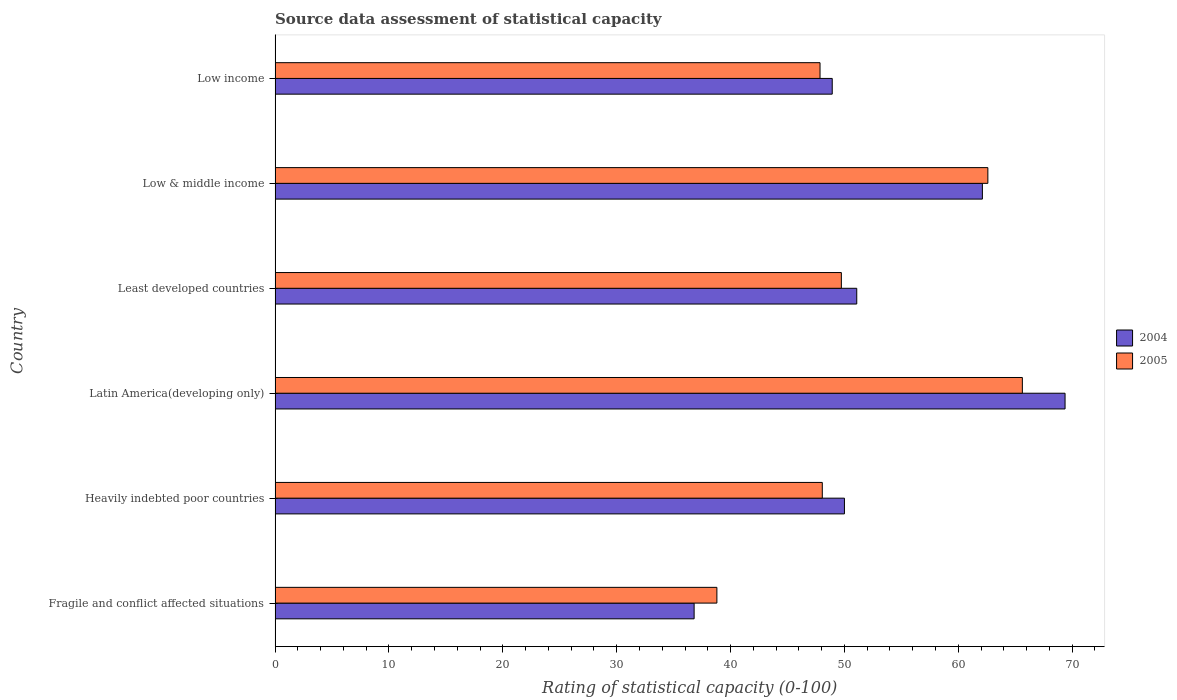How many different coloured bars are there?
Provide a short and direct response. 2. Are the number of bars per tick equal to the number of legend labels?
Give a very brief answer. Yes. Are the number of bars on each tick of the Y-axis equal?
Give a very brief answer. Yes. How many bars are there on the 3rd tick from the top?
Provide a short and direct response. 2. What is the label of the 6th group of bars from the top?
Make the answer very short. Fragile and conflict affected situations. In how many cases, is the number of bars for a given country not equal to the number of legend labels?
Provide a succinct answer. 0. What is the rating of statistical capacity in 2005 in Fragile and conflict affected situations?
Give a very brief answer. 38.8. Across all countries, what is the maximum rating of statistical capacity in 2005?
Ensure brevity in your answer.  65.62. Across all countries, what is the minimum rating of statistical capacity in 2004?
Keep it short and to the point. 36.8. In which country was the rating of statistical capacity in 2005 maximum?
Provide a succinct answer. Latin America(developing only). In which country was the rating of statistical capacity in 2004 minimum?
Offer a terse response. Fragile and conflict affected situations. What is the total rating of statistical capacity in 2005 in the graph?
Your response must be concise. 312.66. What is the difference between the rating of statistical capacity in 2005 in Least developed countries and that in Low income?
Offer a terse response. 1.87. What is the difference between the rating of statistical capacity in 2005 in Least developed countries and the rating of statistical capacity in 2004 in Low & middle income?
Give a very brief answer. -12.39. What is the average rating of statistical capacity in 2004 per country?
Offer a very short reply. 53.05. What is the difference between the rating of statistical capacity in 2004 and rating of statistical capacity in 2005 in Low income?
Make the answer very short. 1.07. In how many countries, is the rating of statistical capacity in 2005 greater than 14 ?
Provide a succinct answer. 6. What is the ratio of the rating of statistical capacity in 2005 in Fragile and conflict affected situations to that in Least developed countries?
Your response must be concise. 0.78. Is the rating of statistical capacity in 2004 in Heavily indebted poor countries less than that in Low & middle income?
Provide a short and direct response. Yes. Is the difference between the rating of statistical capacity in 2004 in Heavily indebted poor countries and Low & middle income greater than the difference between the rating of statistical capacity in 2005 in Heavily indebted poor countries and Low & middle income?
Ensure brevity in your answer.  Yes. What is the difference between the highest and the second highest rating of statistical capacity in 2004?
Your answer should be very brief. 7.26. What is the difference between the highest and the lowest rating of statistical capacity in 2004?
Make the answer very short. 32.58. What does the 2nd bar from the bottom in Least developed countries represents?
Provide a succinct answer. 2005. How many bars are there?
Your response must be concise. 12. Are the values on the major ticks of X-axis written in scientific E-notation?
Make the answer very short. No. Does the graph contain any zero values?
Provide a succinct answer. No. Does the graph contain grids?
Provide a succinct answer. No. Where does the legend appear in the graph?
Make the answer very short. Center right. How many legend labels are there?
Your answer should be compact. 2. What is the title of the graph?
Keep it short and to the point. Source data assessment of statistical capacity. Does "1968" appear as one of the legend labels in the graph?
Provide a succinct answer. No. What is the label or title of the X-axis?
Offer a very short reply. Rating of statistical capacity (0-100). What is the label or title of the Y-axis?
Provide a succinct answer. Country. What is the Rating of statistical capacity (0-100) in 2004 in Fragile and conflict affected situations?
Your answer should be compact. 36.8. What is the Rating of statistical capacity (0-100) of 2005 in Fragile and conflict affected situations?
Your answer should be compact. 38.8. What is the Rating of statistical capacity (0-100) of 2005 in Heavily indebted poor countries?
Provide a short and direct response. 48.06. What is the Rating of statistical capacity (0-100) in 2004 in Latin America(developing only)?
Ensure brevity in your answer.  69.38. What is the Rating of statistical capacity (0-100) in 2005 in Latin America(developing only)?
Your response must be concise. 65.62. What is the Rating of statistical capacity (0-100) of 2004 in Least developed countries?
Provide a short and direct response. 51.08. What is the Rating of statistical capacity (0-100) in 2005 in Least developed countries?
Offer a terse response. 49.73. What is the Rating of statistical capacity (0-100) in 2004 in Low & middle income?
Offer a terse response. 62.12. What is the Rating of statistical capacity (0-100) in 2005 in Low & middle income?
Offer a very short reply. 62.6. What is the Rating of statistical capacity (0-100) of 2004 in Low income?
Give a very brief answer. 48.93. What is the Rating of statistical capacity (0-100) of 2005 in Low income?
Ensure brevity in your answer.  47.86. Across all countries, what is the maximum Rating of statistical capacity (0-100) in 2004?
Ensure brevity in your answer.  69.38. Across all countries, what is the maximum Rating of statistical capacity (0-100) in 2005?
Ensure brevity in your answer.  65.62. Across all countries, what is the minimum Rating of statistical capacity (0-100) of 2004?
Offer a terse response. 36.8. Across all countries, what is the minimum Rating of statistical capacity (0-100) of 2005?
Offer a very short reply. 38.8. What is the total Rating of statistical capacity (0-100) of 2004 in the graph?
Keep it short and to the point. 318.3. What is the total Rating of statistical capacity (0-100) of 2005 in the graph?
Your answer should be very brief. 312.66. What is the difference between the Rating of statistical capacity (0-100) in 2005 in Fragile and conflict affected situations and that in Heavily indebted poor countries?
Offer a very short reply. -9.26. What is the difference between the Rating of statistical capacity (0-100) in 2004 in Fragile and conflict affected situations and that in Latin America(developing only)?
Provide a succinct answer. -32.58. What is the difference between the Rating of statistical capacity (0-100) in 2005 in Fragile and conflict affected situations and that in Latin America(developing only)?
Offer a terse response. -26.82. What is the difference between the Rating of statistical capacity (0-100) in 2004 in Fragile and conflict affected situations and that in Least developed countries?
Provide a short and direct response. -14.28. What is the difference between the Rating of statistical capacity (0-100) in 2005 in Fragile and conflict affected situations and that in Least developed countries?
Provide a succinct answer. -10.93. What is the difference between the Rating of statistical capacity (0-100) of 2004 in Fragile and conflict affected situations and that in Low & middle income?
Offer a terse response. -25.32. What is the difference between the Rating of statistical capacity (0-100) of 2005 in Fragile and conflict affected situations and that in Low & middle income?
Provide a short and direct response. -23.8. What is the difference between the Rating of statistical capacity (0-100) of 2004 in Fragile and conflict affected situations and that in Low income?
Offer a terse response. -12.13. What is the difference between the Rating of statistical capacity (0-100) of 2005 in Fragile and conflict affected situations and that in Low income?
Your response must be concise. -9.06. What is the difference between the Rating of statistical capacity (0-100) of 2004 in Heavily indebted poor countries and that in Latin America(developing only)?
Give a very brief answer. -19.38. What is the difference between the Rating of statistical capacity (0-100) in 2005 in Heavily indebted poor countries and that in Latin America(developing only)?
Ensure brevity in your answer.  -17.57. What is the difference between the Rating of statistical capacity (0-100) of 2004 in Heavily indebted poor countries and that in Least developed countries?
Provide a short and direct response. -1.08. What is the difference between the Rating of statistical capacity (0-100) of 2005 in Heavily indebted poor countries and that in Least developed countries?
Your answer should be very brief. -1.67. What is the difference between the Rating of statistical capacity (0-100) in 2004 in Heavily indebted poor countries and that in Low & middle income?
Give a very brief answer. -12.12. What is the difference between the Rating of statistical capacity (0-100) of 2005 in Heavily indebted poor countries and that in Low & middle income?
Ensure brevity in your answer.  -14.54. What is the difference between the Rating of statistical capacity (0-100) of 2004 in Heavily indebted poor countries and that in Low income?
Provide a succinct answer. 1.07. What is the difference between the Rating of statistical capacity (0-100) in 2005 in Heavily indebted poor countries and that in Low income?
Provide a succinct answer. 0.2. What is the difference between the Rating of statistical capacity (0-100) of 2004 in Latin America(developing only) and that in Least developed countries?
Offer a terse response. 18.29. What is the difference between the Rating of statistical capacity (0-100) in 2005 in Latin America(developing only) and that in Least developed countries?
Keep it short and to the point. 15.9. What is the difference between the Rating of statistical capacity (0-100) in 2004 in Latin America(developing only) and that in Low & middle income?
Ensure brevity in your answer.  7.26. What is the difference between the Rating of statistical capacity (0-100) in 2005 in Latin America(developing only) and that in Low & middle income?
Provide a succinct answer. 3.03. What is the difference between the Rating of statistical capacity (0-100) of 2004 in Latin America(developing only) and that in Low income?
Keep it short and to the point. 20.45. What is the difference between the Rating of statistical capacity (0-100) of 2005 in Latin America(developing only) and that in Low income?
Provide a short and direct response. 17.77. What is the difference between the Rating of statistical capacity (0-100) of 2004 in Least developed countries and that in Low & middle income?
Your answer should be compact. -11.03. What is the difference between the Rating of statistical capacity (0-100) of 2005 in Least developed countries and that in Low & middle income?
Offer a terse response. -12.87. What is the difference between the Rating of statistical capacity (0-100) in 2004 in Least developed countries and that in Low income?
Offer a very short reply. 2.15. What is the difference between the Rating of statistical capacity (0-100) of 2005 in Least developed countries and that in Low income?
Your response must be concise. 1.87. What is the difference between the Rating of statistical capacity (0-100) of 2004 in Low & middle income and that in Low income?
Provide a short and direct response. 13.19. What is the difference between the Rating of statistical capacity (0-100) of 2005 in Low & middle income and that in Low income?
Provide a succinct answer. 14.74. What is the difference between the Rating of statistical capacity (0-100) of 2004 in Fragile and conflict affected situations and the Rating of statistical capacity (0-100) of 2005 in Heavily indebted poor countries?
Your response must be concise. -11.26. What is the difference between the Rating of statistical capacity (0-100) in 2004 in Fragile and conflict affected situations and the Rating of statistical capacity (0-100) in 2005 in Latin America(developing only)?
Offer a very short reply. -28.82. What is the difference between the Rating of statistical capacity (0-100) of 2004 in Fragile and conflict affected situations and the Rating of statistical capacity (0-100) of 2005 in Least developed countries?
Offer a very short reply. -12.93. What is the difference between the Rating of statistical capacity (0-100) of 2004 in Fragile and conflict affected situations and the Rating of statistical capacity (0-100) of 2005 in Low & middle income?
Give a very brief answer. -25.8. What is the difference between the Rating of statistical capacity (0-100) of 2004 in Fragile and conflict affected situations and the Rating of statistical capacity (0-100) of 2005 in Low income?
Give a very brief answer. -11.06. What is the difference between the Rating of statistical capacity (0-100) of 2004 in Heavily indebted poor countries and the Rating of statistical capacity (0-100) of 2005 in Latin America(developing only)?
Your response must be concise. -15.62. What is the difference between the Rating of statistical capacity (0-100) of 2004 in Heavily indebted poor countries and the Rating of statistical capacity (0-100) of 2005 in Least developed countries?
Keep it short and to the point. 0.27. What is the difference between the Rating of statistical capacity (0-100) in 2004 in Heavily indebted poor countries and the Rating of statistical capacity (0-100) in 2005 in Low & middle income?
Provide a succinct answer. -12.6. What is the difference between the Rating of statistical capacity (0-100) in 2004 in Heavily indebted poor countries and the Rating of statistical capacity (0-100) in 2005 in Low income?
Your response must be concise. 2.14. What is the difference between the Rating of statistical capacity (0-100) in 2004 in Latin America(developing only) and the Rating of statistical capacity (0-100) in 2005 in Least developed countries?
Your response must be concise. 19.65. What is the difference between the Rating of statistical capacity (0-100) in 2004 in Latin America(developing only) and the Rating of statistical capacity (0-100) in 2005 in Low & middle income?
Keep it short and to the point. 6.78. What is the difference between the Rating of statistical capacity (0-100) in 2004 in Latin America(developing only) and the Rating of statistical capacity (0-100) in 2005 in Low income?
Your answer should be compact. 21.52. What is the difference between the Rating of statistical capacity (0-100) of 2004 in Least developed countries and the Rating of statistical capacity (0-100) of 2005 in Low & middle income?
Ensure brevity in your answer.  -11.52. What is the difference between the Rating of statistical capacity (0-100) of 2004 in Least developed countries and the Rating of statistical capacity (0-100) of 2005 in Low income?
Provide a succinct answer. 3.22. What is the difference between the Rating of statistical capacity (0-100) of 2004 in Low & middle income and the Rating of statistical capacity (0-100) of 2005 in Low income?
Your answer should be very brief. 14.26. What is the average Rating of statistical capacity (0-100) in 2004 per country?
Keep it short and to the point. 53.05. What is the average Rating of statistical capacity (0-100) in 2005 per country?
Your response must be concise. 52.11. What is the difference between the Rating of statistical capacity (0-100) in 2004 and Rating of statistical capacity (0-100) in 2005 in Heavily indebted poor countries?
Your response must be concise. 1.94. What is the difference between the Rating of statistical capacity (0-100) of 2004 and Rating of statistical capacity (0-100) of 2005 in Latin America(developing only)?
Your answer should be compact. 3.75. What is the difference between the Rating of statistical capacity (0-100) in 2004 and Rating of statistical capacity (0-100) in 2005 in Least developed countries?
Your answer should be compact. 1.35. What is the difference between the Rating of statistical capacity (0-100) of 2004 and Rating of statistical capacity (0-100) of 2005 in Low & middle income?
Your answer should be compact. -0.48. What is the difference between the Rating of statistical capacity (0-100) of 2004 and Rating of statistical capacity (0-100) of 2005 in Low income?
Keep it short and to the point. 1.07. What is the ratio of the Rating of statistical capacity (0-100) in 2004 in Fragile and conflict affected situations to that in Heavily indebted poor countries?
Offer a terse response. 0.74. What is the ratio of the Rating of statistical capacity (0-100) of 2005 in Fragile and conflict affected situations to that in Heavily indebted poor countries?
Ensure brevity in your answer.  0.81. What is the ratio of the Rating of statistical capacity (0-100) of 2004 in Fragile and conflict affected situations to that in Latin America(developing only)?
Ensure brevity in your answer.  0.53. What is the ratio of the Rating of statistical capacity (0-100) of 2005 in Fragile and conflict affected situations to that in Latin America(developing only)?
Offer a terse response. 0.59. What is the ratio of the Rating of statistical capacity (0-100) in 2004 in Fragile and conflict affected situations to that in Least developed countries?
Your answer should be very brief. 0.72. What is the ratio of the Rating of statistical capacity (0-100) in 2005 in Fragile and conflict affected situations to that in Least developed countries?
Your answer should be very brief. 0.78. What is the ratio of the Rating of statistical capacity (0-100) of 2004 in Fragile and conflict affected situations to that in Low & middle income?
Your answer should be very brief. 0.59. What is the ratio of the Rating of statistical capacity (0-100) in 2005 in Fragile and conflict affected situations to that in Low & middle income?
Provide a short and direct response. 0.62. What is the ratio of the Rating of statistical capacity (0-100) in 2004 in Fragile and conflict affected situations to that in Low income?
Offer a terse response. 0.75. What is the ratio of the Rating of statistical capacity (0-100) in 2005 in Fragile and conflict affected situations to that in Low income?
Provide a succinct answer. 0.81. What is the ratio of the Rating of statistical capacity (0-100) of 2004 in Heavily indebted poor countries to that in Latin America(developing only)?
Offer a terse response. 0.72. What is the ratio of the Rating of statistical capacity (0-100) of 2005 in Heavily indebted poor countries to that in Latin America(developing only)?
Keep it short and to the point. 0.73. What is the ratio of the Rating of statistical capacity (0-100) of 2004 in Heavily indebted poor countries to that in Least developed countries?
Your response must be concise. 0.98. What is the ratio of the Rating of statistical capacity (0-100) of 2005 in Heavily indebted poor countries to that in Least developed countries?
Offer a terse response. 0.97. What is the ratio of the Rating of statistical capacity (0-100) in 2004 in Heavily indebted poor countries to that in Low & middle income?
Provide a succinct answer. 0.81. What is the ratio of the Rating of statistical capacity (0-100) in 2005 in Heavily indebted poor countries to that in Low & middle income?
Provide a succinct answer. 0.77. What is the ratio of the Rating of statistical capacity (0-100) in 2004 in Heavily indebted poor countries to that in Low income?
Your answer should be very brief. 1.02. What is the ratio of the Rating of statistical capacity (0-100) of 2004 in Latin America(developing only) to that in Least developed countries?
Make the answer very short. 1.36. What is the ratio of the Rating of statistical capacity (0-100) in 2005 in Latin America(developing only) to that in Least developed countries?
Your answer should be compact. 1.32. What is the ratio of the Rating of statistical capacity (0-100) of 2004 in Latin America(developing only) to that in Low & middle income?
Your response must be concise. 1.12. What is the ratio of the Rating of statistical capacity (0-100) in 2005 in Latin America(developing only) to that in Low & middle income?
Your answer should be very brief. 1.05. What is the ratio of the Rating of statistical capacity (0-100) of 2004 in Latin America(developing only) to that in Low income?
Your response must be concise. 1.42. What is the ratio of the Rating of statistical capacity (0-100) in 2005 in Latin America(developing only) to that in Low income?
Provide a succinct answer. 1.37. What is the ratio of the Rating of statistical capacity (0-100) in 2004 in Least developed countries to that in Low & middle income?
Make the answer very short. 0.82. What is the ratio of the Rating of statistical capacity (0-100) in 2005 in Least developed countries to that in Low & middle income?
Make the answer very short. 0.79. What is the ratio of the Rating of statistical capacity (0-100) of 2004 in Least developed countries to that in Low income?
Offer a very short reply. 1.04. What is the ratio of the Rating of statistical capacity (0-100) in 2005 in Least developed countries to that in Low income?
Make the answer very short. 1.04. What is the ratio of the Rating of statistical capacity (0-100) in 2004 in Low & middle income to that in Low income?
Provide a short and direct response. 1.27. What is the ratio of the Rating of statistical capacity (0-100) of 2005 in Low & middle income to that in Low income?
Offer a terse response. 1.31. What is the difference between the highest and the second highest Rating of statistical capacity (0-100) in 2004?
Ensure brevity in your answer.  7.26. What is the difference between the highest and the second highest Rating of statistical capacity (0-100) in 2005?
Provide a short and direct response. 3.03. What is the difference between the highest and the lowest Rating of statistical capacity (0-100) in 2004?
Provide a succinct answer. 32.58. What is the difference between the highest and the lowest Rating of statistical capacity (0-100) in 2005?
Offer a very short reply. 26.82. 